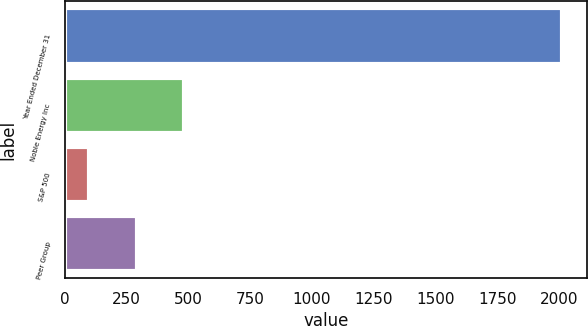<chart> <loc_0><loc_0><loc_500><loc_500><bar_chart><fcel>Year Ended December 31<fcel>Noble Energy Inc<fcel>S&P 500<fcel>Peer Group<nl><fcel>2011<fcel>481.21<fcel>98.75<fcel>289.98<nl></chart> 